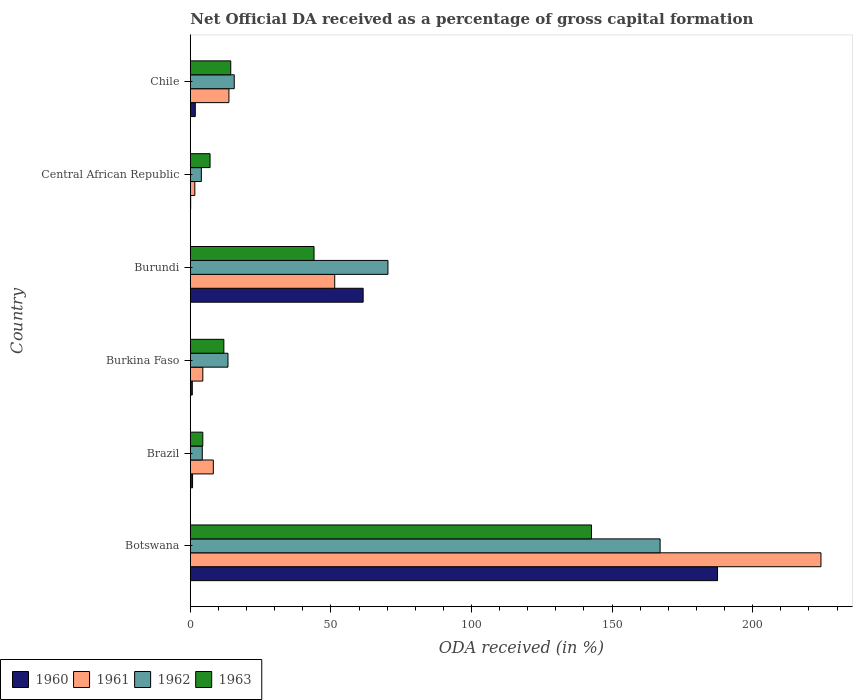How many different coloured bars are there?
Give a very brief answer. 4. How many groups of bars are there?
Your response must be concise. 6. Are the number of bars on each tick of the Y-axis equal?
Provide a short and direct response. Yes. How many bars are there on the 6th tick from the bottom?
Your answer should be compact. 4. What is the label of the 3rd group of bars from the top?
Your answer should be compact. Burundi. What is the net ODA received in 1963 in Burkina Faso?
Make the answer very short. 11.94. Across all countries, what is the maximum net ODA received in 1963?
Your answer should be compact. 142.68. Across all countries, what is the minimum net ODA received in 1961?
Your response must be concise. 1.61. In which country was the net ODA received in 1962 maximum?
Provide a short and direct response. Botswana. In which country was the net ODA received in 1960 minimum?
Your answer should be very brief. Central African Republic. What is the total net ODA received in 1961 in the graph?
Your answer should be very brief. 303.61. What is the difference between the net ODA received in 1962 in Botswana and that in Central African Republic?
Provide a succinct answer. 163.14. What is the difference between the net ODA received in 1960 in Burundi and the net ODA received in 1962 in Brazil?
Keep it short and to the point. 57.21. What is the average net ODA received in 1960 per country?
Keep it short and to the point. 42.06. What is the difference between the net ODA received in 1961 and net ODA received in 1960 in Central African Republic?
Give a very brief answer. 1.47. In how many countries, is the net ODA received in 1962 greater than 140 %?
Your response must be concise. 1. What is the ratio of the net ODA received in 1962 in Burkina Faso to that in Chile?
Keep it short and to the point. 0.86. Is the net ODA received in 1961 in Botswana less than that in Burkina Faso?
Make the answer very short. No. Is the difference between the net ODA received in 1961 in Brazil and Burundi greater than the difference between the net ODA received in 1960 in Brazil and Burundi?
Make the answer very short. Yes. What is the difference between the highest and the second highest net ODA received in 1962?
Ensure brevity in your answer.  96.78. What is the difference between the highest and the lowest net ODA received in 1963?
Offer a very short reply. 138.23. In how many countries, is the net ODA received in 1961 greater than the average net ODA received in 1961 taken over all countries?
Your response must be concise. 2. What does the 1st bar from the top in Burundi represents?
Give a very brief answer. 1963. What does the 1st bar from the bottom in Botswana represents?
Make the answer very short. 1960. Is it the case that in every country, the sum of the net ODA received in 1963 and net ODA received in 1962 is greater than the net ODA received in 1961?
Offer a very short reply. Yes. Are all the bars in the graph horizontal?
Your response must be concise. Yes. What is the difference between two consecutive major ticks on the X-axis?
Keep it short and to the point. 50. Does the graph contain any zero values?
Make the answer very short. No. Does the graph contain grids?
Ensure brevity in your answer.  No. How are the legend labels stacked?
Make the answer very short. Horizontal. What is the title of the graph?
Make the answer very short. Net Official DA received as a percentage of gross capital formation. What is the label or title of the X-axis?
Your answer should be compact. ODA received (in %). What is the ODA received (in %) in 1960 in Botswana?
Your response must be concise. 187.49. What is the ODA received (in %) in 1961 in Botswana?
Keep it short and to the point. 224.27. What is the ODA received (in %) in 1962 in Botswana?
Provide a short and direct response. 167.07. What is the ODA received (in %) of 1963 in Botswana?
Provide a short and direct response. 142.68. What is the ODA received (in %) in 1960 in Brazil?
Give a very brief answer. 0.81. What is the ODA received (in %) in 1961 in Brazil?
Offer a terse response. 8.19. What is the ODA received (in %) in 1962 in Brazil?
Provide a short and direct response. 4.26. What is the ODA received (in %) of 1963 in Brazil?
Your answer should be very brief. 4.45. What is the ODA received (in %) of 1960 in Burkina Faso?
Your answer should be very brief. 0.71. What is the ODA received (in %) of 1961 in Burkina Faso?
Your answer should be very brief. 4.45. What is the ODA received (in %) in 1962 in Burkina Faso?
Offer a very short reply. 13.4. What is the ODA received (in %) of 1963 in Burkina Faso?
Your answer should be compact. 11.94. What is the ODA received (in %) of 1960 in Burundi?
Provide a succinct answer. 61.47. What is the ODA received (in %) in 1961 in Burundi?
Your answer should be very brief. 51.36. What is the ODA received (in %) of 1962 in Burundi?
Offer a very short reply. 70.29. What is the ODA received (in %) in 1960 in Central African Republic?
Your answer should be compact. 0.14. What is the ODA received (in %) in 1961 in Central African Republic?
Your answer should be very brief. 1.61. What is the ODA received (in %) in 1962 in Central African Republic?
Ensure brevity in your answer.  3.93. What is the ODA received (in %) of 1963 in Central African Republic?
Your answer should be compact. 7.03. What is the ODA received (in %) in 1960 in Chile?
Provide a short and direct response. 1.78. What is the ODA received (in %) of 1961 in Chile?
Offer a terse response. 13.73. What is the ODA received (in %) in 1962 in Chile?
Offer a terse response. 15.63. What is the ODA received (in %) of 1963 in Chile?
Your answer should be compact. 14.39. Across all countries, what is the maximum ODA received (in %) of 1960?
Your response must be concise. 187.49. Across all countries, what is the maximum ODA received (in %) of 1961?
Ensure brevity in your answer.  224.27. Across all countries, what is the maximum ODA received (in %) of 1962?
Make the answer very short. 167.07. Across all countries, what is the maximum ODA received (in %) in 1963?
Ensure brevity in your answer.  142.68. Across all countries, what is the minimum ODA received (in %) of 1960?
Your response must be concise. 0.14. Across all countries, what is the minimum ODA received (in %) in 1961?
Ensure brevity in your answer.  1.61. Across all countries, what is the minimum ODA received (in %) of 1962?
Your response must be concise. 3.93. Across all countries, what is the minimum ODA received (in %) of 1963?
Your answer should be very brief. 4.45. What is the total ODA received (in %) of 1960 in the graph?
Offer a terse response. 252.39. What is the total ODA received (in %) of 1961 in the graph?
Make the answer very short. 303.61. What is the total ODA received (in %) in 1962 in the graph?
Keep it short and to the point. 274.58. What is the total ODA received (in %) of 1963 in the graph?
Make the answer very short. 224.48. What is the difference between the ODA received (in %) in 1960 in Botswana and that in Brazil?
Offer a terse response. 186.68. What is the difference between the ODA received (in %) of 1961 in Botswana and that in Brazil?
Offer a terse response. 216.07. What is the difference between the ODA received (in %) of 1962 in Botswana and that in Brazil?
Give a very brief answer. 162.81. What is the difference between the ODA received (in %) of 1963 in Botswana and that in Brazil?
Offer a terse response. 138.23. What is the difference between the ODA received (in %) in 1960 in Botswana and that in Burkina Faso?
Provide a succinct answer. 186.78. What is the difference between the ODA received (in %) in 1961 in Botswana and that in Burkina Faso?
Give a very brief answer. 219.81. What is the difference between the ODA received (in %) of 1962 in Botswana and that in Burkina Faso?
Offer a terse response. 153.67. What is the difference between the ODA received (in %) of 1963 in Botswana and that in Burkina Faso?
Your answer should be compact. 130.74. What is the difference between the ODA received (in %) of 1960 in Botswana and that in Burundi?
Your response must be concise. 126.02. What is the difference between the ODA received (in %) of 1961 in Botswana and that in Burundi?
Your answer should be very brief. 172.91. What is the difference between the ODA received (in %) in 1962 in Botswana and that in Burundi?
Make the answer very short. 96.78. What is the difference between the ODA received (in %) of 1963 in Botswana and that in Burundi?
Keep it short and to the point. 98.68. What is the difference between the ODA received (in %) in 1960 in Botswana and that in Central African Republic?
Offer a terse response. 187.35. What is the difference between the ODA received (in %) in 1961 in Botswana and that in Central African Republic?
Your answer should be compact. 222.66. What is the difference between the ODA received (in %) in 1962 in Botswana and that in Central African Republic?
Offer a terse response. 163.14. What is the difference between the ODA received (in %) of 1963 in Botswana and that in Central African Republic?
Provide a short and direct response. 135.65. What is the difference between the ODA received (in %) in 1960 in Botswana and that in Chile?
Your answer should be compact. 185.71. What is the difference between the ODA received (in %) in 1961 in Botswana and that in Chile?
Provide a short and direct response. 210.53. What is the difference between the ODA received (in %) of 1962 in Botswana and that in Chile?
Provide a short and direct response. 151.44. What is the difference between the ODA received (in %) of 1963 in Botswana and that in Chile?
Offer a very short reply. 128.29. What is the difference between the ODA received (in %) in 1960 in Brazil and that in Burkina Faso?
Your answer should be compact. 0.1. What is the difference between the ODA received (in %) in 1961 in Brazil and that in Burkina Faso?
Your answer should be very brief. 3.74. What is the difference between the ODA received (in %) in 1962 in Brazil and that in Burkina Faso?
Give a very brief answer. -9.14. What is the difference between the ODA received (in %) in 1963 in Brazil and that in Burkina Faso?
Your response must be concise. -7.49. What is the difference between the ODA received (in %) of 1960 in Brazil and that in Burundi?
Make the answer very short. -60.66. What is the difference between the ODA received (in %) in 1961 in Brazil and that in Burundi?
Keep it short and to the point. -43.17. What is the difference between the ODA received (in %) in 1962 in Brazil and that in Burundi?
Offer a terse response. -66.02. What is the difference between the ODA received (in %) in 1963 in Brazil and that in Burundi?
Your response must be concise. -39.55. What is the difference between the ODA received (in %) in 1960 in Brazil and that in Central African Republic?
Your answer should be very brief. 0.67. What is the difference between the ODA received (in %) of 1961 in Brazil and that in Central African Republic?
Offer a terse response. 6.58. What is the difference between the ODA received (in %) of 1962 in Brazil and that in Central African Republic?
Your answer should be compact. 0.33. What is the difference between the ODA received (in %) in 1963 in Brazil and that in Central African Republic?
Your answer should be very brief. -2.58. What is the difference between the ODA received (in %) in 1960 in Brazil and that in Chile?
Your response must be concise. -0.97. What is the difference between the ODA received (in %) in 1961 in Brazil and that in Chile?
Provide a succinct answer. -5.54. What is the difference between the ODA received (in %) in 1962 in Brazil and that in Chile?
Provide a succinct answer. -11.37. What is the difference between the ODA received (in %) in 1963 in Brazil and that in Chile?
Your answer should be compact. -9.94. What is the difference between the ODA received (in %) of 1960 in Burkina Faso and that in Burundi?
Keep it short and to the point. -60.76. What is the difference between the ODA received (in %) in 1961 in Burkina Faso and that in Burundi?
Provide a short and direct response. -46.9. What is the difference between the ODA received (in %) in 1962 in Burkina Faso and that in Burundi?
Your answer should be compact. -56.88. What is the difference between the ODA received (in %) in 1963 in Burkina Faso and that in Burundi?
Your answer should be very brief. -32.06. What is the difference between the ODA received (in %) of 1960 in Burkina Faso and that in Central African Republic?
Keep it short and to the point. 0.57. What is the difference between the ODA received (in %) of 1961 in Burkina Faso and that in Central African Republic?
Your answer should be compact. 2.84. What is the difference between the ODA received (in %) in 1962 in Burkina Faso and that in Central African Republic?
Your answer should be very brief. 9.47. What is the difference between the ODA received (in %) of 1963 in Burkina Faso and that in Central African Republic?
Offer a terse response. 4.91. What is the difference between the ODA received (in %) in 1960 in Burkina Faso and that in Chile?
Offer a terse response. -1.07. What is the difference between the ODA received (in %) of 1961 in Burkina Faso and that in Chile?
Offer a very short reply. -9.28. What is the difference between the ODA received (in %) in 1962 in Burkina Faso and that in Chile?
Your answer should be compact. -2.23. What is the difference between the ODA received (in %) of 1963 in Burkina Faso and that in Chile?
Your answer should be compact. -2.45. What is the difference between the ODA received (in %) of 1960 in Burundi and that in Central African Republic?
Ensure brevity in your answer.  61.33. What is the difference between the ODA received (in %) in 1961 in Burundi and that in Central African Republic?
Your answer should be very brief. 49.75. What is the difference between the ODA received (in %) of 1962 in Burundi and that in Central African Republic?
Give a very brief answer. 66.35. What is the difference between the ODA received (in %) of 1963 in Burundi and that in Central African Republic?
Keep it short and to the point. 36.97. What is the difference between the ODA received (in %) of 1960 in Burundi and that in Chile?
Offer a very short reply. 59.69. What is the difference between the ODA received (in %) in 1961 in Burundi and that in Chile?
Provide a succinct answer. 37.62. What is the difference between the ODA received (in %) in 1962 in Burundi and that in Chile?
Provide a short and direct response. 54.66. What is the difference between the ODA received (in %) in 1963 in Burundi and that in Chile?
Provide a short and direct response. 29.61. What is the difference between the ODA received (in %) in 1960 in Central African Republic and that in Chile?
Make the answer very short. -1.64. What is the difference between the ODA received (in %) in 1961 in Central African Republic and that in Chile?
Keep it short and to the point. -12.12. What is the difference between the ODA received (in %) of 1962 in Central African Republic and that in Chile?
Provide a short and direct response. -11.7. What is the difference between the ODA received (in %) in 1963 in Central African Republic and that in Chile?
Keep it short and to the point. -7.36. What is the difference between the ODA received (in %) of 1960 in Botswana and the ODA received (in %) of 1961 in Brazil?
Give a very brief answer. 179.29. What is the difference between the ODA received (in %) in 1960 in Botswana and the ODA received (in %) in 1962 in Brazil?
Your answer should be very brief. 183.22. What is the difference between the ODA received (in %) in 1960 in Botswana and the ODA received (in %) in 1963 in Brazil?
Your answer should be compact. 183.04. What is the difference between the ODA received (in %) in 1961 in Botswana and the ODA received (in %) in 1962 in Brazil?
Offer a terse response. 220. What is the difference between the ODA received (in %) in 1961 in Botswana and the ODA received (in %) in 1963 in Brazil?
Ensure brevity in your answer.  219.82. What is the difference between the ODA received (in %) of 1962 in Botswana and the ODA received (in %) of 1963 in Brazil?
Your answer should be very brief. 162.62. What is the difference between the ODA received (in %) in 1960 in Botswana and the ODA received (in %) in 1961 in Burkina Faso?
Offer a terse response. 183.03. What is the difference between the ODA received (in %) of 1960 in Botswana and the ODA received (in %) of 1962 in Burkina Faso?
Offer a very short reply. 174.08. What is the difference between the ODA received (in %) of 1960 in Botswana and the ODA received (in %) of 1963 in Burkina Faso?
Provide a short and direct response. 175.55. What is the difference between the ODA received (in %) of 1961 in Botswana and the ODA received (in %) of 1962 in Burkina Faso?
Ensure brevity in your answer.  210.86. What is the difference between the ODA received (in %) in 1961 in Botswana and the ODA received (in %) in 1963 in Burkina Faso?
Offer a terse response. 212.33. What is the difference between the ODA received (in %) of 1962 in Botswana and the ODA received (in %) of 1963 in Burkina Faso?
Keep it short and to the point. 155.13. What is the difference between the ODA received (in %) of 1960 in Botswana and the ODA received (in %) of 1961 in Burundi?
Keep it short and to the point. 136.13. What is the difference between the ODA received (in %) in 1960 in Botswana and the ODA received (in %) in 1962 in Burundi?
Offer a very short reply. 117.2. What is the difference between the ODA received (in %) in 1960 in Botswana and the ODA received (in %) in 1963 in Burundi?
Your response must be concise. 143.49. What is the difference between the ODA received (in %) of 1961 in Botswana and the ODA received (in %) of 1962 in Burundi?
Keep it short and to the point. 153.98. What is the difference between the ODA received (in %) in 1961 in Botswana and the ODA received (in %) in 1963 in Burundi?
Provide a succinct answer. 180.27. What is the difference between the ODA received (in %) in 1962 in Botswana and the ODA received (in %) in 1963 in Burundi?
Ensure brevity in your answer.  123.07. What is the difference between the ODA received (in %) in 1960 in Botswana and the ODA received (in %) in 1961 in Central African Republic?
Give a very brief answer. 185.88. What is the difference between the ODA received (in %) in 1960 in Botswana and the ODA received (in %) in 1962 in Central African Republic?
Your response must be concise. 183.55. What is the difference between the ODA received (in %) of 1960 in Botswana and the ODA received (in %) of 1963 in Central African Republic?
Your answer should be compact. 180.46. What is the difference between the ODA received (in %) in 1961 in Botswana and the ODA received (in %) in 1962 in Central African Republic?
Offer a terse response. 220.33. What is the difference between the ODA received (in %) in 1961 in Botswana and the ODA received (in %) in 1963 in Central African Republic?
Your answer should be compact. 217.24. What is the difference between the ODA received (in %) of 1962 in Botswana and the ODA received (in %) of 1963 in Central African Republic?
Offer a very short reply. 160.04. What is the difference between the ODA received (in %) of 1960 in Botswana and the ODA received (in %) of 1961 in Chile?
Keep it short and to the point. 173.75. What is the difference between the ODA received (in %) in 1960 in Botswana and the ODA received (in %) in 1962 in Chile?
Your response must be concise. 171.86. What is the difference between the ODA received (in %) in 1960 in Botswana and the ODA received (in %) in 1963 in Chile?
Give a very brief answer. 173.1. What is the difference between the ODA received (in %) in 1961 in Botswana and the ODA received (in %) in 1962 in Chile?
Your answer should be compact. 208.64. What is the difference between the ODA received (in %) in 1961 in Botswana and the ODA received (in %) in 1963 in Chile?
Ensure brevity in your answer.  209.88. What is the difference between the ODA received (in %) of 1962 in Botswana and the ODA received (in %) of 1963 in Chile?
Your response must be concise. 152.68. What is the difference between the ODA received (in %) in 1960 in Brazil and the ODA received (in %) in 1961 in Burkina Faso?
Provide a succinct answer. -3.65. What is the difference between the ODA received (in %) in 1960 in Brazil and the ODA received (in %) in 1962 in Burkina Faso?
Your response must be concise. -12.6. What is the difference between the ODA received (in %) of 1960 in Brazil and the ODA received (in %) of 1963 in Burkina Faso?
Keep it short and to the point. -11.13. What is the difference between the ODA received (in %) of 1961 in Brazil and the ODA received (in %) of 1962 in Burkina Faso?
Give a very brief answer. -5.21. What is the difference between the ODA received (in %) in 1961 in Brazil and the ODA received (in %) in 1963 in Burkina Faso?
Your answer should be compact. -3.75. What is the difference between the ODA received (in %) in 1962 in Brazil and the ODA received (in %) in 1963 in Burkina Faso?
Your response must be concise. -7.67. What is the difference between the ODA received (in %) of 1960 in Brazil and the ODA received (in %) of 1961 in Burundi?
Your answer should be compact. -50.55. What is the difference between the ODA received (in %) in 1960 in Brazil and the ODA received (in %) in 1962 in Burundi?
Offer a very short reply. -69.48. What is the difference between the ODA received (in %) of 1960 in Brazil and the ODA received (in %) of 1963 in Burundi?
Provide a succinct answer. -43.19. What is the difference between the ODA received (in %) in 1961 in Brazil and the ODA received (in %) in 1962 in Burundi?
Your answer should be compact. -62.09. What is the difference between the ODA received (in %) of 1961 in Brazil and the ODA received (in %) of 1963 in Burundi?
Your response must be concise. -35.81. What is the difference between the ODA received (in %) in 1962 in Brazil and the ODA received (in %) in 1963 in Burundi?
Ensure brevity in your answer.  -39.74. What is the difference between the ODA received (in %) in 1960 in Brazil and the ODA received (in %) in 1961 in Central African Republic?
Provide a succinct answer. -0.8. What is the difference between the ODA received (in %) in 1960 in Brazil and the ODA received (in %) in 1962 in Central African Republic?
Make the answer very short. -3.13. What is the difference between the ODA received (in %) of 1960 in Brazil and the ODA received (in %) of 1963 in Central African Republic?
Your answer should be very brief. -6.22. What is the difference between the ODA received (in %) in 1961 in Brazil and the ODA received (in %) in 1962 in Central African Republic?
Your answer should be compact. 4.26. What is the difference between the ODA received (in %) in 1961 in Brazil and the ODA received (in %) in 1963 in Central African Republic?
Offer a terse response. 1.16. What is the difference between the ODA received (in %) in 1962 in Brazil and the ODA received (in %) in 1963 in Central African Republic?
Make the answer very short. -2.77. What is the difference between the ODA received (in %) in 1960 in Brazil and the ODA received (in %) in 1961 in Chile?
Ensure brevity in your answer.  -12.93. What is the difference between the ODA received (in %) of 1960 in Brazil and the ODA received (in %) of 1962 in Chile?
Offer a very short reply. -14.82. What is the difference between the ODA received (in %) of 1960 in Brazil and the ODA received (in %) of 1963 in Chile?
Your response must be concise. -13.58. What is the difference between the ODA received (in %) in 1961 in Brazil and the ODA received (in %) in 1962 in Chile?
Provide a succinct answer. -7.44. What is the difference between the ODA received (in %) of 1961 in Brazil and the ODA received (in %) of 1963 in Chile?
Ensure brevity in your answer.  -6.2. What is the difference between the ODA received (in %) of 1962 in Brazil and the ODA received (in %) of 1963 in Chile?
Your answer should be very brief. -10.12. What is the difference between the ODA received (in %) in 1960 in Burkina Faso and the ODA received (in %) in 1961 in Burundi?
Your response must be concise. -50.65. What is the difference between the ODA received (in %) in 1960 in Burkina Faso and the ODA received (in %) in 1962 in Burundi?
Provide a short and direct response. -69.58. What is the difference between the ODA received (in %) in 1960 in Burkina Faso and the ODA received (in %) in 1963 in Burundi?
Keep it short and to the point. -43.29. What is the difference between the ODA received (in %) in 1961 in Burkina Faso and the ODA received (in %) in 1962 in Burundi?
Offer a very short reply. -65.83. What is the difference between the ODA received (in %) of 1961 in Burkina Faso and the ODA received (in %) of 1963 in Burundi?
Your answer should be compact. -39.55. What is the difference between the ODA received (in %) in 1962 in Burkina Faso and the ODA received (in %) in 1963 in Burundi?
Your answer should be very brief. -30.6. What is the difference between the ODA received (in %) in 1960 in Burkina Faso and the ODA received (in %) in 1961 in Central African Republic?
Offer a very short reply. -0.9. What is the difference between the ODA received (in %) in 1960 in Burkina Faso and the ODA received (in %) in 1962 in Central African Republic?
Provide a succinct answer. -3.22. What is the difference between the ODA received (in %) in 1960 in Burkina Faso and the ODA received (in %) in 1963 in Central African Republic?
Provide a succinct answer. -6.32. What is the difference between the ODA received (in %) of 1961 in Burkina Faso and the ODA received (in %) of 1962 in Central African Republic?
Your answer should be very brief. 0.52. What is the difference between the ODA received (in %) in 1961 in Burkina Faso and the ODA received (in %) in 1963 in Central African Republic?
Provide a short and direct response. -2.58. What is the difference between the ODA received (in %) of 1962 in Burkina Faso and the ODA received (in %) of 1963 in Central African Republic?
Your answer should be very brief. 6.37. What is the difference between the ODA received (in %) in 1960 in Burkina Faso and the ODA received (in %) in 1961 in Chile?
Make the answer very short. -13.02. What is the difference between the ODA received (in %) in 1960 in Burkina Faso and the ODA received (in %) in 1962 in Chile?
Make the answer very short. -14.92. What is the difference between the ODA received (in %) in 1960 in Burkina Faso and the ODA received (in %) in 1963 in Chile?
Offer a very short reply. -13.68. What is the difference between the ODA received (in %) in 1961 in Burkina Faso and the ODA received (in %) in 1962 in Chile?
Keep it short and to the point. -11.18. What is the difference between the ODA received (in %) in 1961 in Burkina Faso and the ODA received (in %) in 1963 in Chile?
Ensure brevity in your answer.  -9.93. What is the difference between the ODA received (in %) of 1962 in Burkina Faso and the ODA received (in %) of 1963 in Chile?
Ensure brevity in your answer.  -0.98. What is the difference between the ODA received (in %) of 1960 in Burundi and the ODA received (in %) of 1961 in Central African Republic?
Keep it short and to the point. 59.86. What is the difference between the ODA received (in %) in 1960 in Burundi and the ODA received (in %) in 1962 in Central African Republic?
Ensure brevity in your answer.  57.54. What is the difference between the ODA received (in %) of 1960 in Burundi and the ODA received (in %) of 1963 in Central African Republic?
Provide a succinct answer. 54.44. What is the difference between the ODA received (in %) of 1961 in Burundi and the ODA received (in %) of 1962 in Central African Republic?
Provide a succinct answer. 47.42. What is the difference between the ODA received (in %) of 1961 in Burundi and the ODA received (in %) of 1963 in Central African Republic?
Your response must be concise. 44.33. What is the difference between the ODA received (in %) in 1962 in Burundi and the ODA received (in %) in 1963 in Central African Republic?
Provide a short and direct response. 63.25. What is the difference between the ODA received (in %) of 1960 in Burundi and the ODA received (in %) of 1961 in Chile?
Offer a terse response. 47.73. What is the difference between the ODA received (in %) of 1960 in Burundi and the ODA received (in %) of 1962 in Chile?
Give a very brief answer. 45.84. What is the difference between the ODA received (in %) of 1960 in Burundi and the ODA received (in %) of 1963 in Chile?
Your response must be concise. 47.08. What is the difference between the ODA received (in %) in 1961 in Burundi and the ODA received (in %) in 1962 in Chile?
Your response must be concise. 35.73. What is the difference between the ODA received (in %) of 1961 in Burundi and the ODA received (in %) of 1963 in Chile?
Your response must be concise. 36.97. What is the difference between the ODA received (in %) of 1962 in Burundi and the ODA received (in %) of 1963 in Chile?
Give a very brief answer. 55.9. What is the difference between the ODA received (in %) of 1960 in Central African Republic and the ODA received (in %) of 1961 in Chile?
Offer a terse response. -13.6. What is the difference between the ODA received (in %) of 1960 in Central African Republic and the ODA received (in %) of 1962 in Chile?
Offer a terse response. -15.49. What is the difference between the ODA received (in %) of 1960 in Central African Republic and the ODA received (in %) of 1963 in Chile?
Offer a terse response. -14.25. What is the difference between the ODA received (in %) of 1961 in Central African Republic and the ODA received (in %) of 1962 in Chile?
Your answer should be very brief. -14.02. What is the difference between the ODA received (in %) of 1961 in Central African Republic and the ODA received (in %) of 1963 in Chile?
Your answer should be compact. -12.78. What is the difference between the ODA received (in %) of 1962 in Central African Republic and the ODA received (in %) of 1963 in Chile?
Offer a terse response. -10.45. What is the average ODA received (in %) in 1960 per country?
Offer a terse response. 42.06. What is the average ODA received (in %) in 1961 per country?
Make the answer very short. 50.6. What is the average ODA received (in %) in 1962 per country?
Make the answer very short. 45.76. What is the average ODA received (in %) of 1963 per country?
Ensure brevity in your answer.  37.41. What is the difference between the ODA received (in %) of 1960 and ODA received (in %) of 1961 in Botswana?
Keep it short and to the point. -36.78. What is the difference between the ODA received (in %) of 1960 and ODA received (in %) of 1962 in Botswana?
Give a very brief answer. 20.42. What is the difference between the ODA received (in %) in 1960 and ODA received (in %) in 1963 in Botswana?
Ensure brevity in your answer.  44.81. What is the difference between the ODA received (in %) in 1961 and ODA received (in %) in 1962 in Botswana?
Give a very brief answer. 57.2. What is the difference between the ODA received (in %) of 1961 and ODA received (in %) of 1963 in Botswana?
Make the answer very short. 81.59. What is the difference between the ODA received (in %) in 1962 and ODA received (in %) in 1963 in Botswana?
Ensure brevity in your answer.  24.39. What is the difference between the ODA received (in %) in 1960 and ODA received (in %) in 1961 in Brazil?
Ensure brevity in your answer.  -7.38. What is the difference between the ODA received (in %) in 1960 and ODA received (in %) in 1962 in Brazil?
Offer a very short reply. -3.46. What is the difference between the ODA received (in %) of 1960 and ODA received (in %) of 1963 in Brazil?
Provide a short and direct response. -3.64. What is the difference between the ODA received (in %) of 1961 and ODA received (in %) of 1962 in Brazil?
Provide a short and direct response. 3.93. What is the difference between the ODA received (in %) of 1961 and ODA received (in %) of 1963 in Brazil?
Your answer should be very brief. 3.74. What is the difference between the ODA received (in %) of 1962 and ODA received (in %) of 1963 in Brazil?
Offer a very short reply. -0.18. What is the difference between the ODA received (in %) in 1960 and ODA received (in %) in 1961 in Burkina Faso?
Make the answer very short. -3.74. What is the difference between the ODA received (in %) of 1960 and ODA received (in %) of 1962 in Burkina Faso?
Your answer should be very brief. -12.69. What is the difference between the ODA received (in %) in 1960 and ODA received (in %) in 1963 in Burkina Faso?
Keep it short and to the point. -11.23. What is the difference between the ODA received (in %) of 1961 and ODA received (in %) of 1962 in Burkina Faso?
Provide a short and direct response. -8.95. What is the difference between the ODA received (in %) of 1961 and ODA received (in %) of 1963 in Burkina Faso?
Provide a succinct answer. -7.48. What is the difference between the ODA received (in %) in 1962 and ODA received (in %) in 1963 in Burkina Faso?
Offer a terse response. 1.47. What is the difference between the ODA received (in %) in 1960 and ODA received (in %) in 1961 in Burundi?
Your answer should be very brief. 10.11. What is the difference between the ODA received (in %) of 1960 and ODA received (in %) of 1962 in Burundi?
Provide a short and direct response. -8.82. What is the difference between the ODA received (in %) of 1960 and ODA received (in %) of 1963 in Burundi?
Make the answer very short. 17.47. What is the difference between the ODA received (in %) in 1961 and ODA received (in %) in 1962 in Burundi?
Keep it short and to the point. -18.93. What is the difference between the ODA received (in %) in 1961 and ODA received (in %) in 1963 in Burundi?
Your response must be concise. 7.36. What is the difference between the ODA received (in %) of 1962 and ODA received (in %) of 1963 in Burundi?
Keep it short and to the point. 26.29. What is the difference between the ODA received (in %) of 1960 and ODA received (in %) of 1961 in Central African Republic?
Ensure brevity in your answer.  -1.47. What is the difference between the ODA received (in %) in 1960 and ODA received (in %) in 1962 in Central African Republic?
Provide a short and direct response. -3.8. What is the difference between the ODA received (in %) in 1960 and ODA received (in %) in 1963 in Central African Republic?
Keep it short and to the point. -6.89. What is the difference between the ODA received (in %) of 1961 and ODA received (in %) of 1962 in Central African Republic?
Offer a very short reply. -2.32. What is the difference between the ODA received (in %) in 1961 and ODA received (in %) in 1963 in Central African Republic?
Your response must be concise. -5.42. What is the difference between the ODA received (in %) of 1962 and ODA received (in %) of 1963 in Central African Republic?
Make the answer very short. -3.1. What is the difference between the ODA received (in %) in 1960 and ODA received (in %) in 1961 in Chile?
Keep it short and to the point. -11.96. What is the difference between the ODA received (in %) in 1960 and ODA received (in %) in 1962 in Chile?
Ensure brevity in your answer.  -13.85. What is the difference between the ODA received (in %) in 1960 and ODA received (in %) in 1963 in Chile?
Offer a terse response. -12.61. What is the difference between the ODA received (in %) of 1961 and ODA received (in %) of 1962 in Chile?
Keep it short and to the point. -1.89. What is the difference between the ODA received (in %) of 1961 and ODA received (in %) of 1963 in Chile?
Your answer should be compact. -0.65. What is the difference between the ODA received (in %) of 1962 and ODA received (in %) of 1963 in Chile?
Offer a terse response. 1.24. What is the ratio of the ODA received (in %) of 1960 in Botswana to that in Brazil?
Provide a short and direct response. 232.07. What is the ratio of the ODA received (in %) in 1961 in Botswana to that in Brazil?
Your answer should be very brief. 27.38. What is the ratio of the ODA received (in %) in 1962 in Botswana to that in Brazil?
Offer a terse response. 39.18. What is the ratio of the ODA received (in %) in 1963 in Botswana to that in Brazil?
Your response must be concise. 32.07. What is the ratio of the ODA received (in %) in 1960 in Botswana to that in Burkina Faso?
Provide a short and direct response. 263.92. What is the ratio of the ODA received (in %) in 1961 in Botswana to that in Burkina Faso?
Give a very brief answer. 50.35. What is the ratio of the ODA received (in %) of 1962 in Botswana to that in Burkina Faso?
Make the answer very short. 12.46. What is the ratio of the ODA received (in %) of 1963 in Botswana to that in Burkina Faso?
Provide a short and direct response. 11.95. What is the ratio of the ODA received (in %) in 1960 in Botswana to that in Burundi?
Your answer should be very brief. 3.05. What is the ratio of the ODA received (in %) in 1961 in Botswana to that in Burundi?
Provide a short and direct response. 4.37. What is the ratio of the ODA received (in %) in 1962 in Botswana to that in Burundi?
Your answer should be compact. 2.38. What is the ratio of the ODA received (in %) of 1963 in Botswana to that in Burundi?
Give a very brief answer. 3.24. What is the ratio of the ODA received (in %) of 1960 in Botswana to that in Central African Republic?
Keep it short and to the point. 1376.35. What is the ratio of the ODA received (in %) in 1961 in Botswana to that in Central African Republic?
Your response must be concise. 139.34. What is the ratio of the ODA received (in %) in 1962 in Botswana to that in Central African Republic?
Offer a terse response. 42.47. What is the ratio of the ODA received (in %) in 1963 in Botswana to that in Central African Republic?
Offer a very short reply. 20.29. What is the ratio of the ODA received (in %) of 1960 in Botswana to that in Chile?
Keep it short and to the point. 105.39. What is the ratio of the ODA received (in %) in 1961 in Botswana to that in Chile?
Offer a very short reply. 16.33. What is the ratio of the ODA received (in %) in 1962 in Botswana to that in Chile?
Ensure brevity in your answer.  10.69. What is the ratio of the ODA received (in %) of 1963 in Botswana to that in Chile?
Your response must be concise. 9.92. What is the ratio of the ODA received (in %) of 1960 in Brazil to that in Burkina Faso?
Provide a short and direct response. 1.14. What is the ratio of the ODA received (in %) of 1961 in Brazil to that in Burkina Faso?
Ensure brevity in your answer.  1.84. What is the ratio of the ODA received (in %) of 1962 in Brazil to that in Burkina Faso?
Ensure brevity in your answer.  0.32. What is the ratio of the ODA received (in %) in 1963 in Brazil to that in Burkina Faso?
Offer a terse response. 0.37. What is the ratio of the ODA received (in %) in 1960 in Brazil to that in Burundi?
Provide a short and direct response. 0.01. What is the ratio of the ODA received (in %) of 1961 in Brazil to that in Burundi?
Keep it short and to the point. 0.16. What is the ratio of the ODA received (in %) in 1962 in Brazil to that in Burundi?
Provide a succinct answer. 0.06. What is the ratio of the ODA received (in %) in 1963 in Brazil to that in Burundi?
Keep it short and to the point. 0.1. What is the ratio of the ODA received (in %) in 1960 in Brazil to that in Central African Republic?
Provide a succinct answer. 5.93. What is the ratio of the ODA received (in %) in 1961 in Brazil to that in Central African Republic?
Make the answer very short. 5.09. What is the ratio of the ODA received (in %) in 1962 in Brazil to that in Central African Republic?
Keep it short and to the point. 1.08. What is the ratio of the ODA received (in %) of 1963 in Brazil to that in Central African Republic?
Your answer should be very brief. 0.63. What is the ratio of the ODA received (in %) in 1960 in Brazil to that in Chile?
Your answer should be compact. 0.45. What is the ratio of the ODA received (in %) of 1961 in Brazil to that in Chile?
Keep it short and to the point. 0.6. What is the ratio of the ODA received (in %) in 1962 in Brazil to that in Chile?
Make the answer very short. 0.27. What is the ratio of the ODA received (in %) in 1963 in Brazil to that in Chile?
Offer a very short reply. 0.31. What is the ratio of the ODA received (in %) in 1960 in Burkina Faso to that in Burundi?
Ensure brevity in your answer.  0.01. What is the ratio of the ODA received (in %) of 1961 in Burkina Faso to that in Burundi?
Offer a very short reply. 0.09. What is the ratio of the ODA received (in %) of 1962 in Burkina Faso to that in Burundi?
Keep it short and to the point. 0.19. What is the ratio of the ODA received (in %) in 1963 in Burkina Faso to that in Burundi?
Your response must be concise. 0.27. What is the ratio of the ODA received (in %) of 1960 in Burkina Faso to that in Central African Republic?
Make the answer very short. 5.21. What is the ratio of the ODA received (in %) of 1961 in Burkina Faso to that in Central African Republic?
Give a very brief answer. 2.77. What is the ratio of the ODA received (in %) in 1962 in Burkina Faso to that in Central African Republic?
Offer a terse response. 3.41. What is the ratio of the ODA received (in %) of 1963 in Burkina Faso to that in Central African Republic?
Your answer should be compact. 1.7. What is the ratio of the ODA received (in %) in 1960 in Burkina Faso to that in Chile?
Keep it short and to the point. 0.4. What is the ratio of the ODA received (in %) of 1961 in Burkina Faso to that in Chile?
Your answer should be very brief. 0.32. What is the ratio of the ODA received (in %) of 1962 in Burkina Faso to that in Chile?
Provide a succinct answer. 0.86. What is the ratio of the ODA received (in %) of 1963 in Burkina Faso to that in Chile?
Make the answer very short. 0.83. What is the ratio of the ODA received (in %) in 1960 in Burundi to that in Central African Republic?
Give a very brief answer. 451.25. What is the ratio of the ODA received (in %) in 1961 in Burundi to that in Central African Republic?
Provide a short and direct response. 31.91. What is the ratio of the ODA received (in %) in 1962 in Burundi to that in Central African Republic?
Ensure brevity in your answer.  17.87. What is the ratio of the ODA received (in %) of 1963 in Burundi to that in Central African Republic?
Provide a short and direct response. 6.26. What is the ratio of the ODA received (in %) in 1960 in Burundi to that in Chile?
Ensure brevity in your answer.  34.55. What is the ratio of the ODA received (in %) of 1961 in Burundi to that in Chile?
Offer a terse response. 3.74. What is the ratio of the ODA received (in %) in 1962 in Burundi to that in Chile?
Keep it short and to the point. 4.5. What is the ratio of the ODA received (in %) in 1963 in Burundi to that in Chile?
Provide a succinct answer. 3.06. What is the ratio of the ODA received (in %) of 1960 in Central African Republic to that in Chile?
Your answer should be very brief. 0.08. What is the ratio of the ODA received (in %) in 1961 in Central African Republic to that in Chile?
Your response must be concise. 0.12. What is the ratio of the ODA received (in %) in 1962 in Central African Republic to that in Chile?
Provide a succinct answer. 0.25. What is the ratio of the ODA received (in %) of 1963 in Central African Republic to that in Chile?
Provide a short and direct response. 0.49. What is the difference between the highest and the second highest ODA received (in %) of 1960?
Give a very brief answer. 126.02. What is the difference between the highest and the second highest ODA received (in %) in 1961?
Your answer should be compact. 172.91. What is the difference between the highest and the second highest ODA received (in %) in 1962?
Your answer should be compact. 96.78. What is the difference between the highest and the second highest ODA received (in %) in 1963?
Your answer should be very brief. 98.68. What is the difference between the highest and the lowest ODA received (in %) of 1960?
Ensure brevity in your answer.  187.35. What is the difference between the highest and the lowest ODA received (in %) of 1961?
Provide a short and direct response. 222.66. What is the difference between the highest and the lowest ODA received (in %) in 1962?
Ensure brevity in your answer.  163.14. What is the difference between the highest and the lowest ODA received (in %) in 1963?
Offer a terse response. 138.23. 